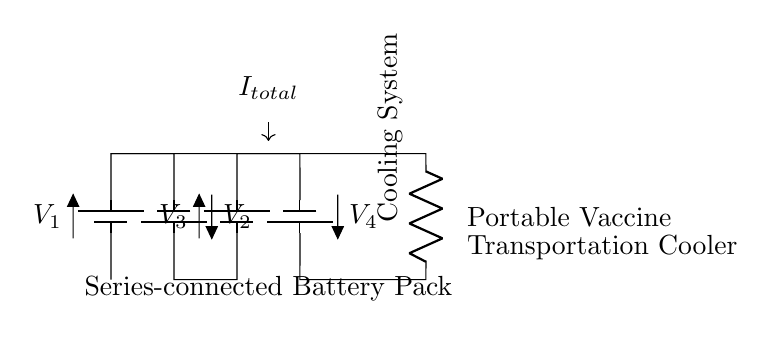What components are in this circuit? The diagram shows four batteries and a resistor labeled as the cooling system.
Answer: four batteries and a resistor What is the total current in the circuit? The current flowing through the circuit is denoted as I_total, which represents the total current supplied by the series arrangement of batteries.
Answer: I_total What is the purpose of the resistor? The cooling system is represented as a resistor, which regulates the current to maintain a specific temperature for the vaccines during transport.
Answer: temperature regulation How are the batteries connected? The batteries are connected in series, which increases the total voltage while maintaining the same current throughout the circuit.
Answer: in series What happens to the voltage when more batteries are added in series? Adding more batteries in series increases the total voltage of the circuit as each battery contributes its voltage to the total.
Answer: increases What is the function of the battery pack? The series-connected battery pack provides power to the cooling system, which is necessary for maintaining the appropriate conditions for vaccine transport.
Answer: power supply What is the main application of this circuit? The primary application of the circuit is for powering portable coolers used in vaccine transportation.
Answer: vaccine transportation 